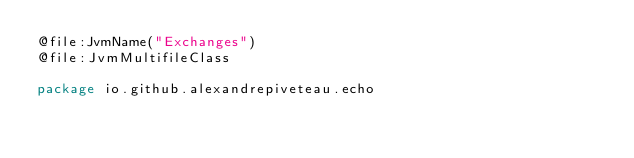<code> <loc_0><loc_0><loc_500><loc_500><_Kotlin_>@file:JvmName("Exchanges")
@file:JvmMultifileClass

package io.github.alexandrepiveteau.echo
</code> 